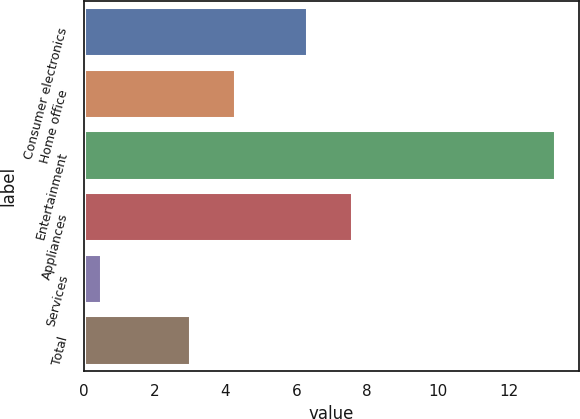Convert chart. <chart><loc_0><loc_0><loc_500><loc_500><bar_chart><fcel>Consumer electronics<fcel>Home office<fcel>Entertainment<fcel>Appliances<fcel>Services<fcel>Total<nl><fcel>6.3<fcel>4.28<fcel>13.3<fcel>7.58<fcel>0.5<fcel>3<nl></chart> 